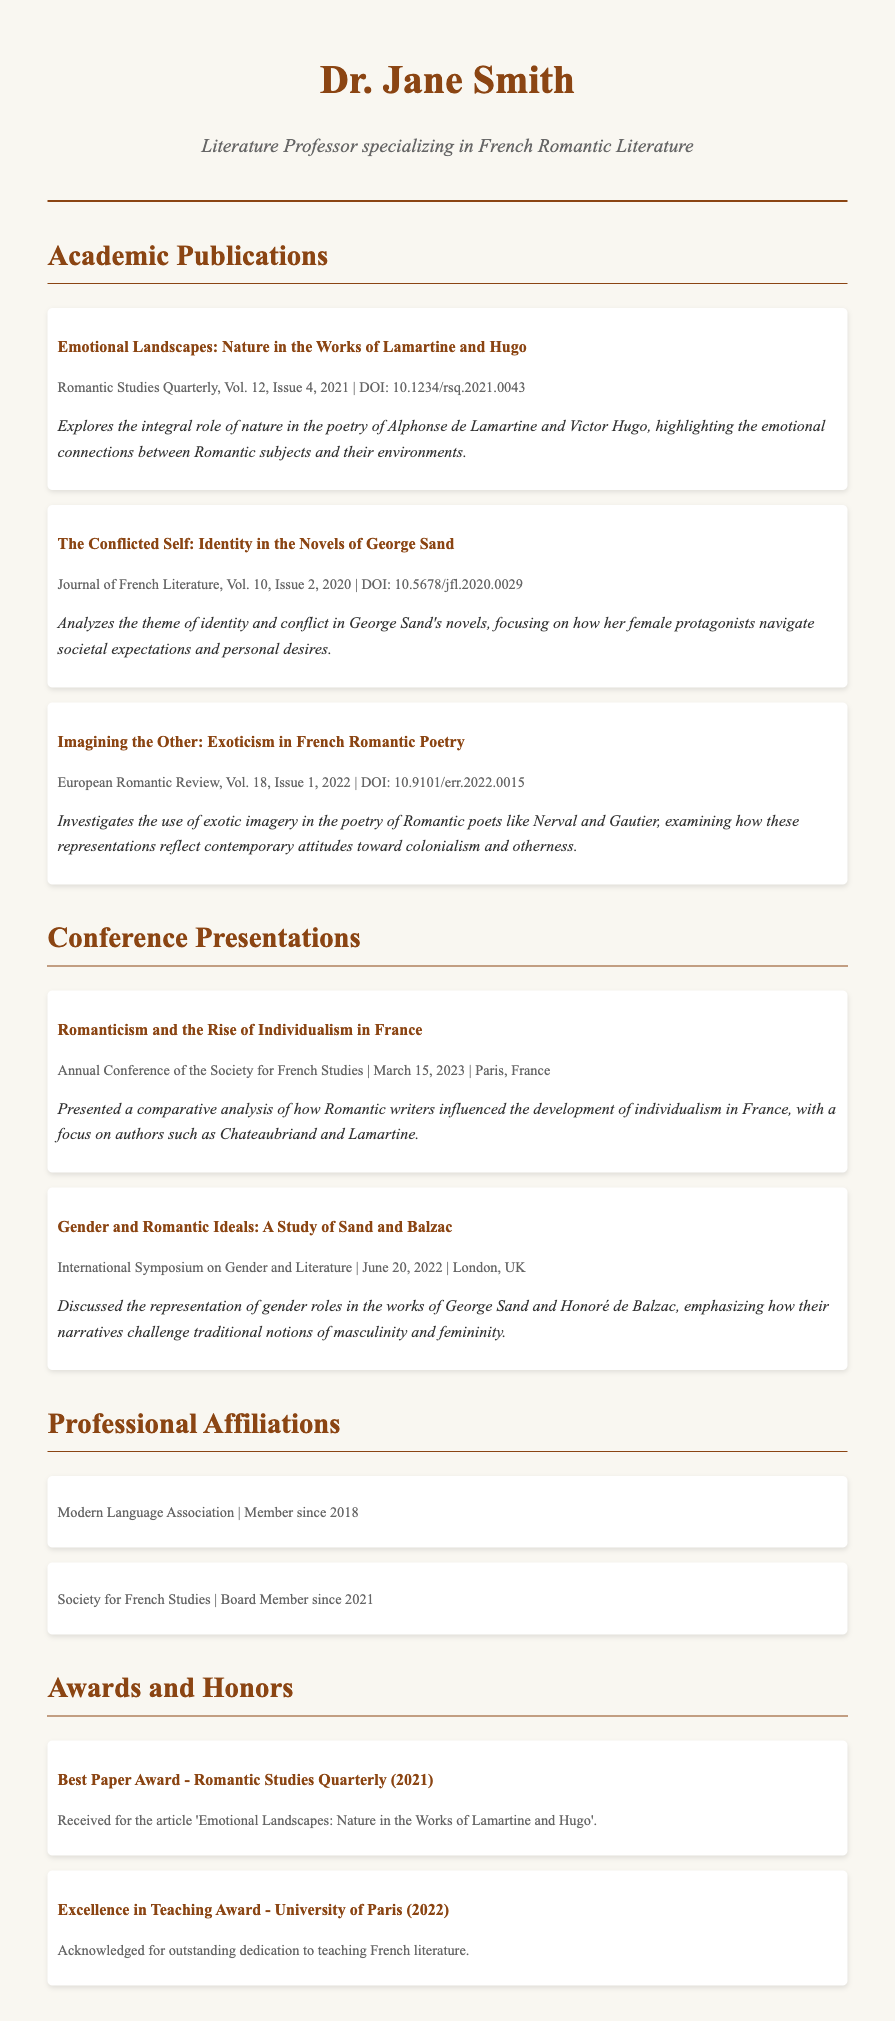what is the title of Dr. Jane Smith's publication in 2021? The title can be found in the Academic Publications section and is "Emotional Landscapes: Nature in the Works of Lamartine and Hugo".
Answer: Emotional Landscapes: Nature in the Works of Lamartine and Hugo which journal published the article about Gender and Romantic Ideals? This information is located in the Conference Presentations section, where it states the event was the "International Symposium on Gender and Literature".
Answer: International Symposium on Gender and Literature how many conference presentations are listed in the CV? The CV lists the number of presentations under the Conference Presentations section, which shows there are two presentations.
Answer: 2 who is the author of the article focusing on identity in novels? This information can be found in the publication details where it states the author is George Sand.
Answer: George Sand what award did Dr. Jane Smith receive in 2021? The award is detailed under the Awards and Honors section stating "Best Paper Award - Romantic Studies Quarterly (2021)" was received.
Answer: Best Paper Award - Romantic Studies Quarterly (2021) which professional organization has Dr. Jane Smith served as a board member? The CV notes that Dr. Jane Smith is a Board Member of the "Society for French Studies" since 2021.
Answer: Society for French Studies which two authors are discussed in the conference presentation titled "Romanticism and the Rise of Individualism in France"? This information is gathered from the summary of the presentation, stating it focuses on Chateaubriand and Lamartine.
Answer: Chateaubriand and Lamartine what is the volume and issue number of the publication about exoticism? The details in the publication specify it is found in "European Romantic Review, Vol. 18, Issue 1, 2022".
Answer: Vol. 18, Issue 1, 2022 